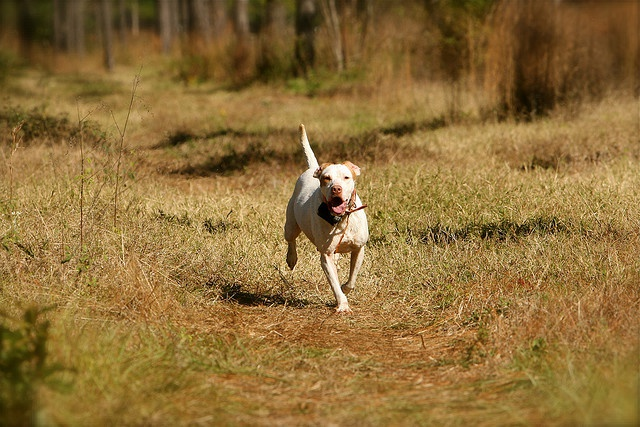Describe the objects in this image and their specific colors. I can see a dog in black, ivory, maroon, and tan tones in this image. 